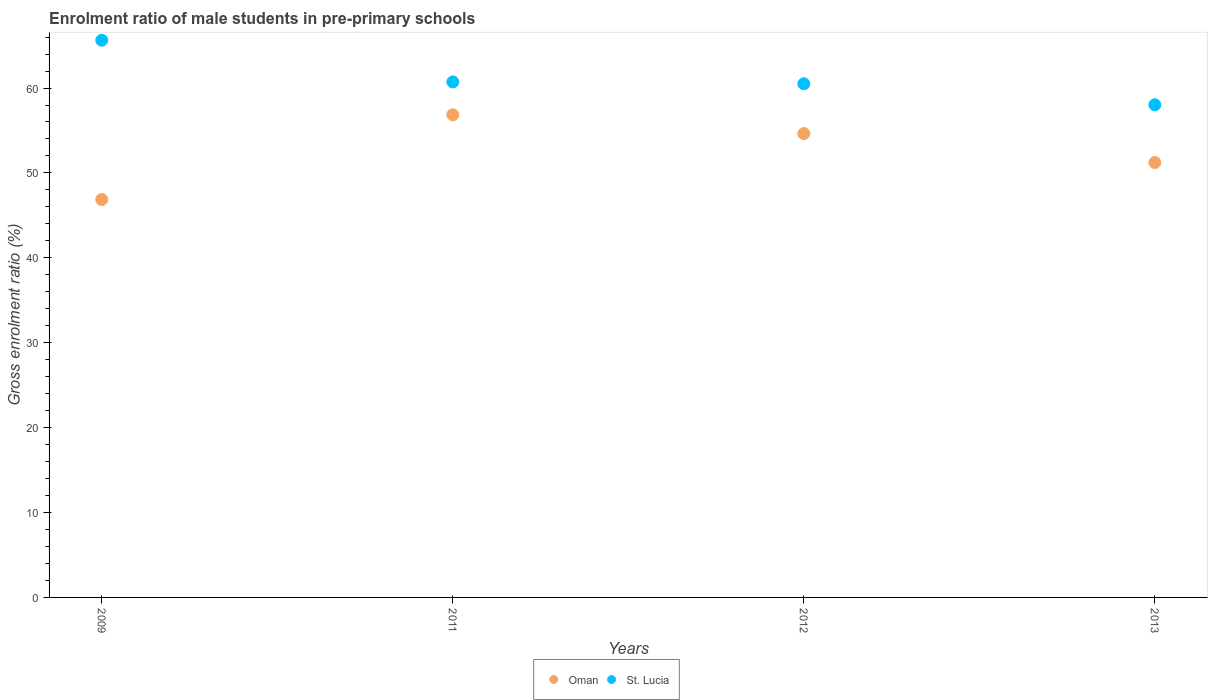How many different coloured dotlines are there?
Provide a short and direct response. 2. What is the enrolment ratio of male students in pre-primary schools in St. Lucia in 2013?
Your answer should be compact. 58.03. Across all years, what is the maximum enrolment ratio of male students in pre-primary schools in Oman?
Offer a very short reply. 56.85. Across all years, what is the minimum enrolment ratio of male students in pre-primary schools in Oman?
Make the answer very short. 46.87. What is the total enrolment ratio of male students in pre-primary schools in St. Lucia in the graph?
Provide a succinct answer. 244.89. What is the difference between the enrolment ratio of male students in pre-primary schools in St. Lucia in 2009 and that in 2012?
Keep it short and to the point. 5.13. What is the difference between the enrolment ratio of male students in pre-primary schools in St. Lucia in 2013 and the enrolment ratio of male students in pre-primary schools in Oman in 2012?
Your answer should be very brief. 3.39. What is the average enrolment ratio of male students in pre-primary schools in Oman per year?
Provide a short and direct response. 52.4. In the year 2012, what is the difference between the enrolment ratio of male students in pre-primary schools in Oman and enrolment ratio of male students in pre-primary schools in St. Lucia?
Make the answer very short. -5.87. What is the ratio of the enrolment ratio of male students in pre-primary schools in St. Lucia in 2011 to that in 2012?
Offer a very short reply. 1. Is the enrolment ratio of male students in pre-primary schools in St. Lucia in 2011 less than that in 2013?
Offer a very short reply. No. Is the difference between the enrolment ratio of male students in pre-primary schools in Oman in 2009 and 2013 greater than the difference between the enrolment ratio of male students in pre-primary schools in St. Lucia in 2009 and 2013?
Provide a short and direct response. No. What is the difference between the highest and the second highest enrolment ratio of male students in pre-primary schools in Oman?
Make the answer very short. 2.21. What is the difference between the highest and the lowest enrolment ratio of male students in pre-primary schools in St. Lucia?
Offer a terse response. 7.61. How many dotlines are there?
Ensure brevity in your answer.  2. How many years are there in the graph?
Give a very brief answer. 4. What is the difference between two consecutive major ticks on the Y-axis?
Your answer should be very brief. 10. Does the graph contain any zero values?
Make the answer very short. No. Does the graph contain grids?
Your answer should be very brief. No. Where does the legend appear in the graph?
Your response must be concise. Bottom center. How are the legend labels stacked?
Ensure brevity in your answer.  Horizontal. What is the title of the graph?
Your response must be concise. Enrolment ratio of male students in pre-primary schools. Does "Djibouti" appear as one of the legend labels in the graph?
Provide a short and direct response. No. What is the label or title of the X-axis?
Ensure brevity in your answer.  Years. What is the label or title of the Y-axis?
Your response must be concise. Gross enrolment ratio (%). What is the Gross enrolment ratio (%) in Oman in 2009?
Your answer should be compact. 46.87. What is the Gross enrolment ratio (%) in St. Lucia in 2009?
Provide a succinct answer. 65.63. What is the Gross enrolment ratio (%) in Oman in 2011?
Provide a succinct answer. 56.85. What is the Gross enrolment ratio (%) in St. Lucia in 2011?
Provide a succinct answer. 60.72. What is the Gross enrolment ratio (%) of Oman in 2012?
Provide a succinct answer. 54.64. What is the Gross enrolment ratio (%) of St. Lucia in 2012?
Keep it short and to the point. 60.51. What is the Gross enrolment ratio (%) in Oman in 2013?
Your answer should be very brief. 51.23. What is the Gross enrolment ratio (%) of St. Lucia in 2013?
Give a very brief answer. 58.03. Across all years, what is the maximum Gross enrolment ratio (%) in Oman?
Offer a terse response. 56.85. Across all years, what is the maximum Gross enrolment ratio (%) of St. Lucia?
Your answer should be compact. 65.63. Across all years, what is the minimum Gross enrolment ratio (%) in Oman?
Keep it short and to the point. 46.87. Across all years, what is the minimum Gross enrolment ratio (%) in St. Lucia?
Give a very brief answer. 58.03. What is the total Gross enrolment ratio (%) of Oman in the graph?
Keep it short and to the point. 209.58. What is the total Gross enrolment ratio (%) of St. Lucia in the graph?
Make the answer very short. 244.89. What is the difference between the Gross enrolment ratio (%) of Oman in 2009 and that in 2011?
Your response must be concise. -9.98. What is the difference between the Gross enrolment ratio (%) in St. Lucia in 2009 and that in 2011?
Provide a succinct answer. 4.91. What is the difference between the Gross enrolment ratio (%) in Oman in 2009 and that in 2012?
Provide a succinct answer. -7.77. What is the difference between the Gross enrolment ratio (%) of St. Lucia in 2009 and that in 2012?
Your answer should be very brief. 5.13. What is the difference between the Gross enrolment ratio (%) in Oman in 2009 and that in 2013?
Make the answer very short. -4.36. What is the difference between the Gross enrolment ratio (%) in St. Lucia in 2009 and that in 2013?
Offer a terse response. 7.61. What is the difference between the Gross enrolment ratio (%) of Oman in 2011 and that in 2012?
Provide a succinct answer. 2.21. What is the difference between the Gross enrolment ratio (%) of St. Lucia in 2011 and that in 2012?
Make the answer very short. 0.21. What is the difference between the Gross enrolment ratio (%) of Oman in 2011 and that in 2013?
Make the answer very short. 5.62. What is the difference between the Gross enrolment ratio (%) of St. Lucia in 2011 and that in 2013?
Provide a succinct answer. 2.69. What is the difference between the Gross enrolment ratio (%) in Oman in 2012 and that in 2013?
Keep it short and to the point. 3.41. What is the difference between the Gross enrolment ratio (%) of St. Lucia in 2012 and that in 2013?
Your response must be concise. 2.48. What is the difference between the Gross enrolment ratio (%) in Oman in 2009 and the Gross enrolment ratio (%) in St. Lucia in 2011?
Ensure brevity in your answer.  -13.85. What is the difference between the Gross enrolment ratio (%) of Oman in 2009 and the Gross enrolment ratio (%) of St. Lucia in 2012?
Provide a short and direct response. -13.64. What is the difference between the Gross enrolment ratio (%) in Oman in 2009 and the Gross enrolment ratio (%) in St. Lucia in 2013?
Your answer should be very brief. -11.16. What is the difference between the Gross enrolment ratio (%) in Oman in 2011 and the Gross enrolment ratio (%) in St. Lucia in 2012?
Give a very brief answer. -3.66. What is the difference between the Gross enrolment ratio (%) in Oman in 2011 and the Gross enrolment ratio (%) in St. Lucia in 2013?
Make the answer very short. -1.18. What is the difference between the Gross enrolment ratio (%) in Oman in 2012 and the Gross enrolment ratio (%) in St. Lucia in 2013?
Provide a short and direct response. -3.39. What is the average Gross enrolment ratio (%) of Oman per year?
Ensure brevity in your answer.  52.4. What is the average Gross enrolment ratio (%) in St. Lucia per year?
Make the answer very short. 61.22. In the year 2009, what is the difference between the Gross enrolment ratio (%) of Oman and Gross enrolment ratio (%) of St. Lucia?
Your answer should be compact. -18.76. In the year 2011, what is the difference between the Gross enrolment ratio (%) of Oman and Gross enrolment ratio (%) of St. Lucia?
Keep it short and to the point. -3.87. In the year 2012, what is the difference between the Gross enrolment ratio (%) of Oman and Gross enrolment ratio (%) of St. Lucia?
Offer a terse response. -5.87. In the year 2013, what is the difference between the Gross enrolment ratio (%) in Oman and Gross enrolment ratio (%) in St. Lucia?
Make the answer very short. -6.8. What is the ratio of the Gross enrolment ratio (%) in Oman in 2009 to that in 2011?
Provide a short and direct response. 0.82. What is the ratio of the Gross enrolment ratio (%) of St. Lucia in 2009 to that in 2011?
Offer a terse response. 1.08. What is the ratio of the Gross enrolment ratio (%) in Oman in 2009 to that in 2012?
Offer a terse response. 0.86. What is the ratio of the Gross enrolment ratio (%) of St. Lucia in 2009 to that in 2012?
Your answer should be very brief. 1.08. What is the ratio of the Gross enrolment ratio (%) of Oman in 2009 to that in 2013?
Give a very brief answer. 0.92. What is the ratio of the Gross enrolment ratio (%) in St. Lucia in 2009 to that in 2013?
Offer a terse response. 1.13. What is the ratio of the Gross enrolment ratio (%) of Oman in 2011 to that in 2012?
Offer a terse response. 1.04. What is the ratio of the Gross enrolment ratio (%) of St. Lucia in 2011 to that in 2012?
Provide a succinct answer. 1. What is the ratio of the Gross enrolment ratio (%) in Oman in 2011 to that in 2013?
Ensure brevity in your answer.  1.11. What is the ratio of the Gross enrolment ratio (%) in St. Lucia in 2011 to that in 2013?
Provide a succinct answer. 1.05. What is the ratio of the Gross enrolment ratio (%) in Oman in 2012 to that in 2013?
Keep it short and to the point. 1.07. What is the ratio of the Gross enrolment ratio (%) in St. Lucia in 2012 to that in 2013?
Provide a succinct answer. 1.04. What is the difference between the highest and the second highest Gross enrolment ratio (%) of Oman?
Offer a very short reply. 2.21. What is the difference between the highest and the second highest Gross enrolment ratio (%) in St. Lucia?
Your response must be concise. 4.91. What is the difference between the highest and the lowest Gross enrolment ratio (%) of Oman?
Your answer should be compact. 9.98. What is the difference between the highest and the lowest Gross enrolment ratio (%) in St. Lucia?
Offer a very short reply. 7.61. 